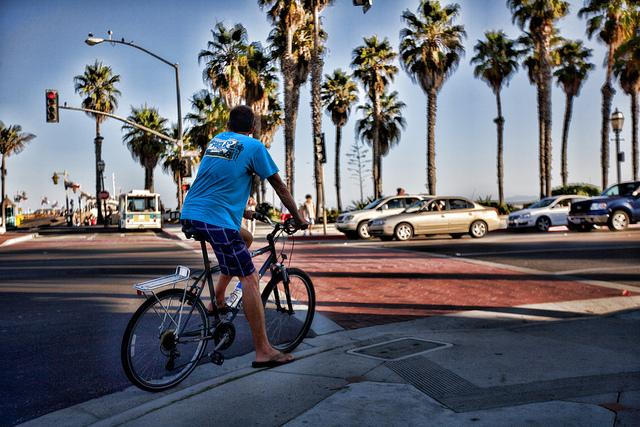What kind of transportation is shown? bicycle 